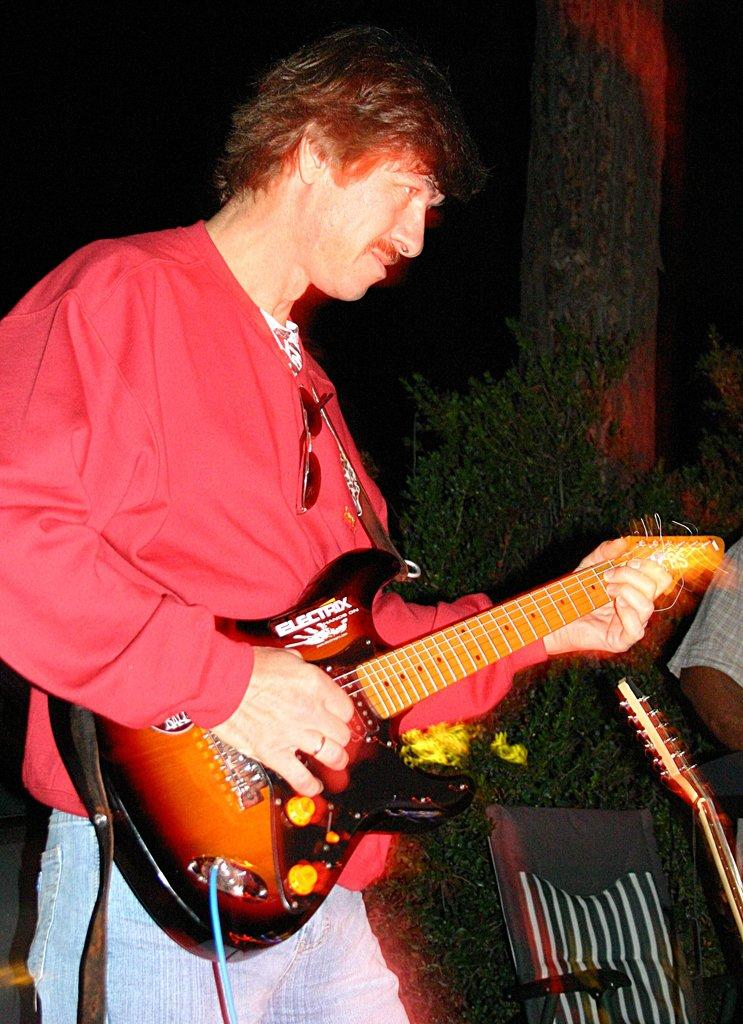What is the main subject of the image? There is a person in the image. What is the person holding in the image? The person is holding a guitar. What type of cake is being protested in the image? There is no cake or protest present in the image; it features a person holding a guitar. What color is the thread used to sew the guitar in the image? There is no thread visible in the image, as the guitar appears to be a solid object. 